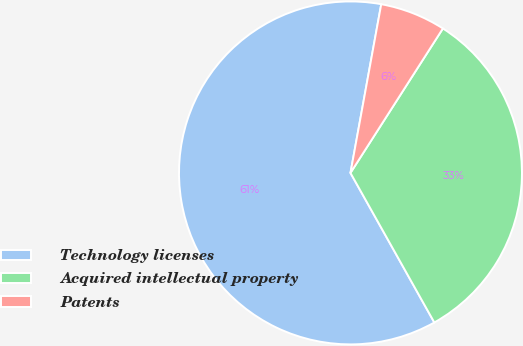<chart> <loc_0><loc_0><loc_500><loc_500><pie_chart><fcel>Technology licenses<fcel>Acquired intellectual property<fcel>Patents<nl><fcel>61.01%<fcel>32.81%<fcel>6.19%<nl></chart> 